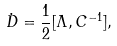Convert formula to latex. <formula><loc_0><loc_0><loc_500><loc_500>\dot { D } = \frac { 1 } { 2 } [ \Lambda , C ^ { - 1 } ] ,</formula> 